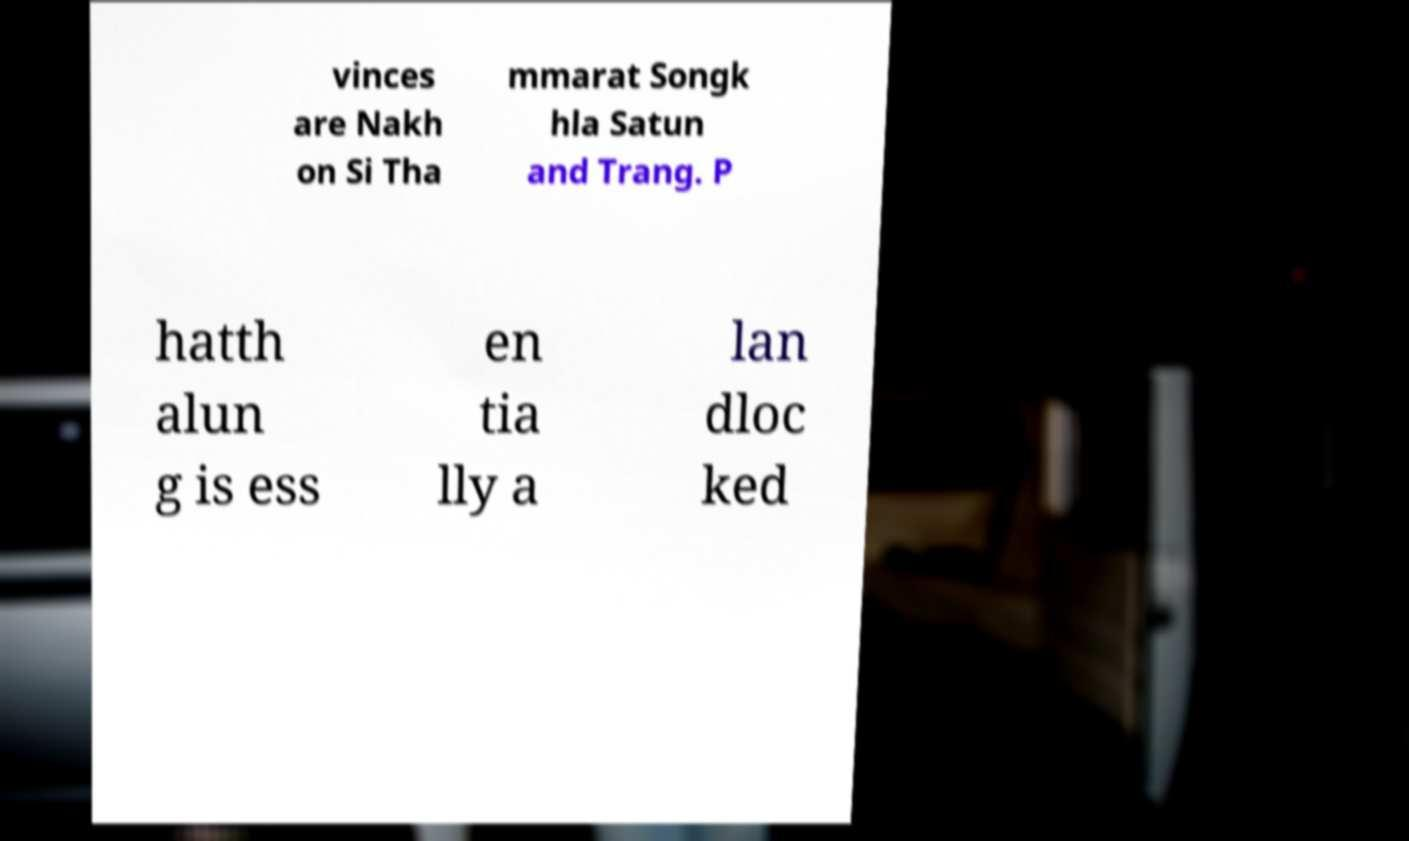Can you read and provide the text displayed in the image?This photo seems to have some interesting text. Can you extract and type it out for me? vinces are Nakh on Si Tha mmarat Songk hla Satun and Trang. P hatth alun g is ess en tia lly a lan dloc ked 